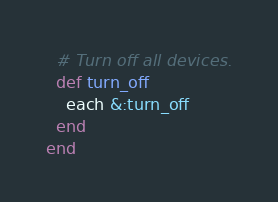<code> <loc_0><loc_0><loc_500><loc_500><_Ruby_>
  # Turn off all devices.
  def turn_off
    each &:turn_off
  end
end</code> 